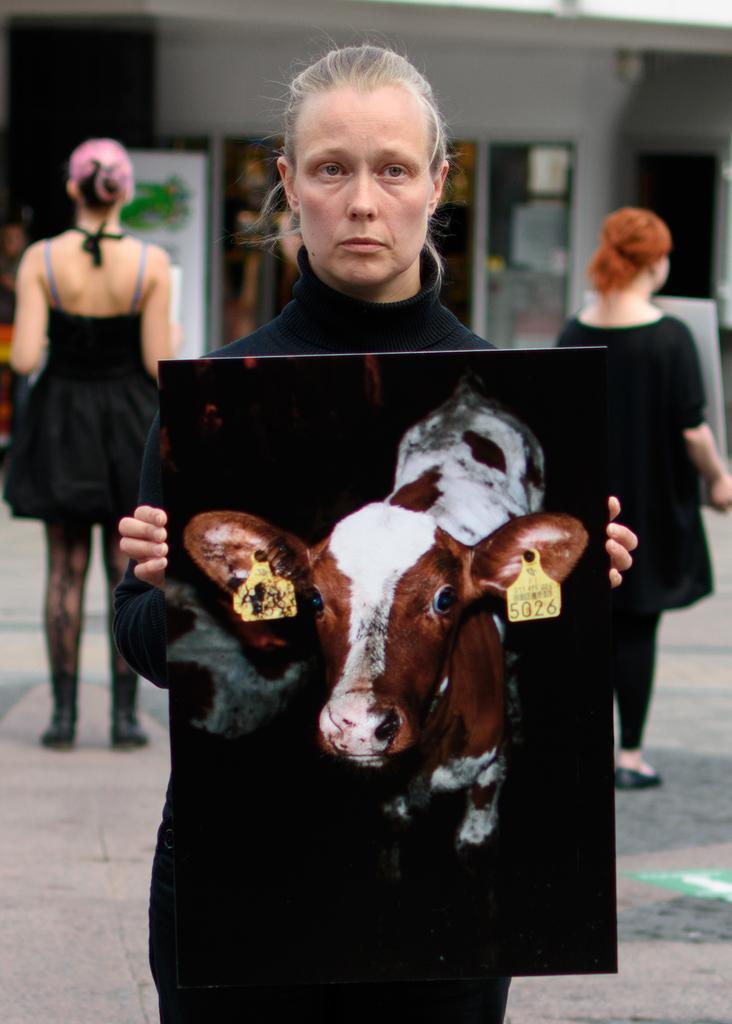In one or two sentences, can you explain what this image depicts? In this picture we can see a few people are standing and holding some painted boards. 